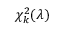Convert formula to latex. <formula><loc_0><loc_0><loc_500><loc_500>\chi _ { k } ^ { 2 } ( \lambda )</formula> 